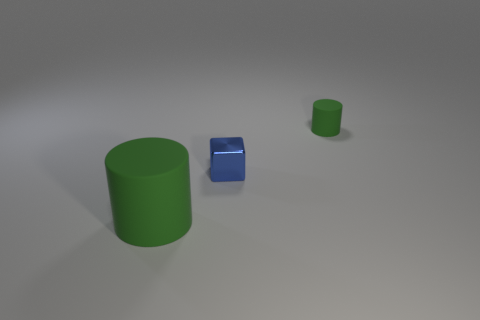There is a blue block left of the green matte thing behind the big cylinder to the left of the blue metal thing; how big is it? The blue block appears to be relatively small in size, especially when compared to the larger green cylinder on its right. Though perspective can affect the appearance of size in images, the blue block's dimensions seem to be compact, suggesting a smaller volume overall. 